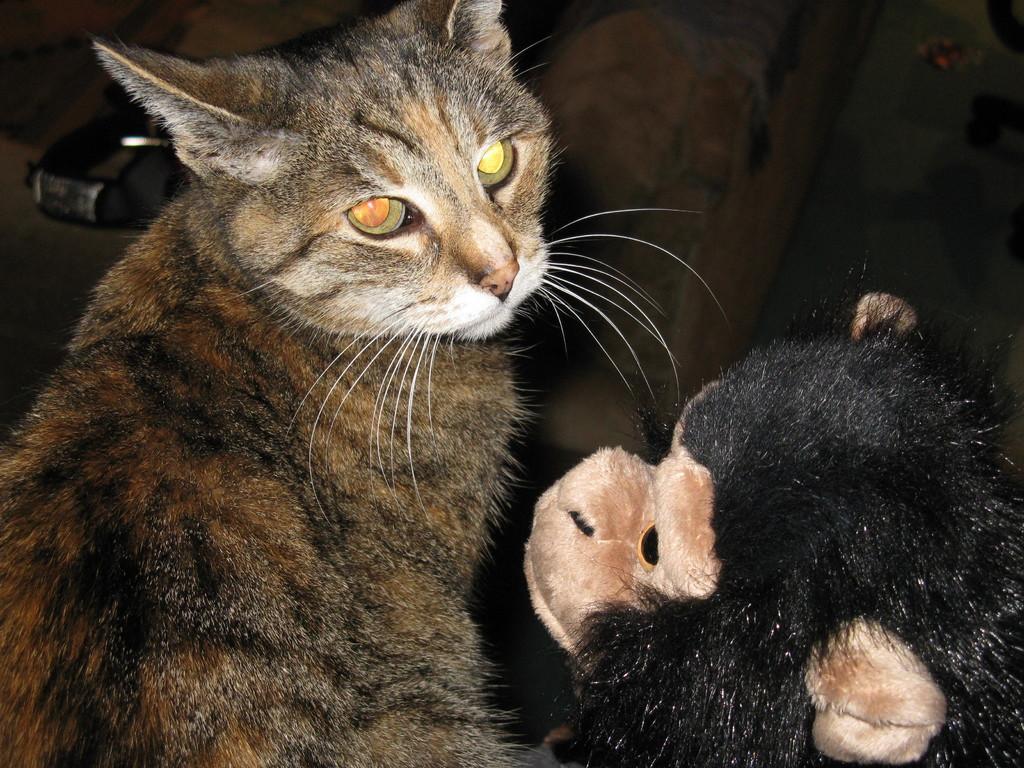Please provide a concise description of this image. In this image there is a cat and a toy monkey. 